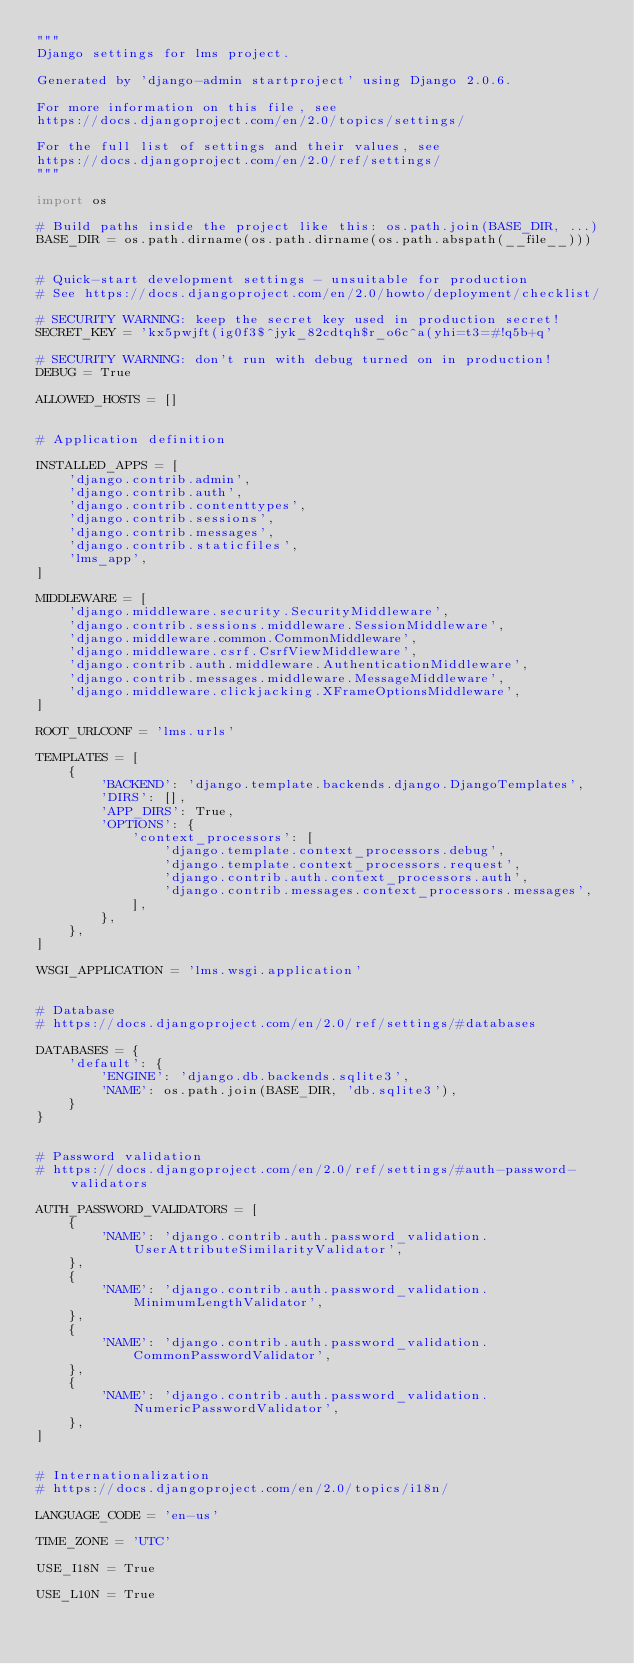<code> <loc_0><loc_0><loc_500><loc_500><_Python_>"""
Django settings for lms project.

Generated by 'django-admin startproject' using Django 2.0.6.

For more information on this file, see
https://docs.djangoproject.com/en/2.0/topics/settings/

For the full list of settings and their values, see
https://docs.djangoproject.com/en/2.0/ref/settings/
"""

import os

# Build paths inside the project like this: os.path.join(BASE_DIR, ...)
BASE_DIR = os.path.dirname(os.path.dirname(os.path.abspath(__file__)))


# Quick-start development settings - unsuitable for production
# See https://docs.djangoproject.com/en/2.0/howto/deployment/checklist/

# SECURITY WARNING: keep the secret key used in production secret!
SECRET_KEY = 'kx5pwjft(ig0f3$^jyk_82cdtqh$r_o6c^a(yhi=t3=#!q5b+q'

# SECURITY WARNING: don't run with debug turned on in production!
DEBUG = True

ALLOWED_HOSTS = []


# Application definition

INSTALLED_APPS = [
    'django.contrib.admin',
    'django.contrib.auth',
    'django.contrib.contenttypes',
    'django.contrib.sessions',
    'django.contrib.messages',
    'django.contrib.staticfiles',
    'lms_app',
]

MIDDLEWARE = [
    'django.middleware.security.SecurityMiddleware',
    'django.contrib.sessions.middleware.SessionMiddleware',
    'django.middleware.common.CommonMiddleware',
    'django.middleware.csrf.CsrfViewMiddleware',
    'django.contrib.auth.middleware.AuthenticationMiddleware',
    'django.contrib.messages.middleware.MessageMiddleware',
    'django.middleware.clickjacking.XFrameOptionsMiddleware',
]

ROOT_URLCONF = 'lms.urls'

TEMPLATES = [
    {
        'BACKEND': 'django.template.backends.django.DjangoTemplates',
        'DIRS': [],
        'APP_DIRS': True,
        'OPTIONS': {
            'context_processors': [
                'django.template.context_processors.debug',
                'django.template.context_processors.request',
                'django.contrib.auth.context_processors.auth',
                'django.contrib.messages.context_processors.messages',
            ],
        },
    },
]

WSGI_APPLICATION = 'lms.wsgi.application'


# Database
# https://docs.djangoproject.com/en/2.0/ref/settings/#databases

DATABASES = {
    'default': {
        'ENGINE': 'django.db.backends.sqlite3',
        'NAME': os.path.join(BASE_DIR, 'db.sqlite3'),
    }
}


# Password validation
# https://docs.djangoproject.com/en/2.0/ref/settings/#auth-password-validators

AUTH_PASSWORD_VALIDATORS = [
    {
        'NAME': 'django.contrib.auth.password_validation.UserAttributeSimilarityValidator',
    },
    {
        'NAME': 'django.contrib.auth.password_validation.MinimumLengthValidator',
    },
    {
        'NAME': 'django.contrib.auth.password_validation.CommonPasswordValidator',
    },
    {
        'NAME': 'django.contrib.auth.password_validation.NumericPasswordValidator',
    },
]


# Internationalization
# https://docs.djangoproject.com/en/2.0/topics/i18n/

LANGUAGE_CODE = 'en-us'

TIME_ZONE = 'UTC'

USE_I18N = True

USE_L10N = True
</code> 